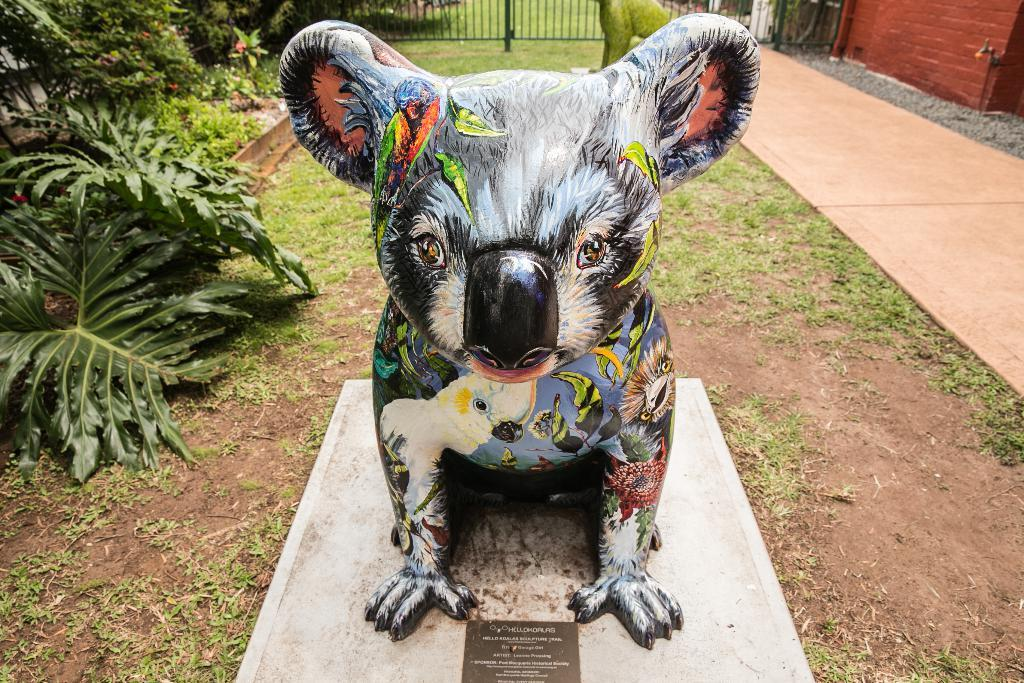What is the main subject in the center of the image? There is a sculpture of an animal in the center of the image. What can be seen in the background of the image? There are plants and green grass in the background of the image. What type of structure is visible in the background? There is a wall in the background of the image, and a metal gate is also visible. Can you tell me how many kitties are playing with the sculpture in the image? There are no kitties present in the image; it features a sculpture of an animal with a background of plants, green grass, a wall, and a metal gate. 